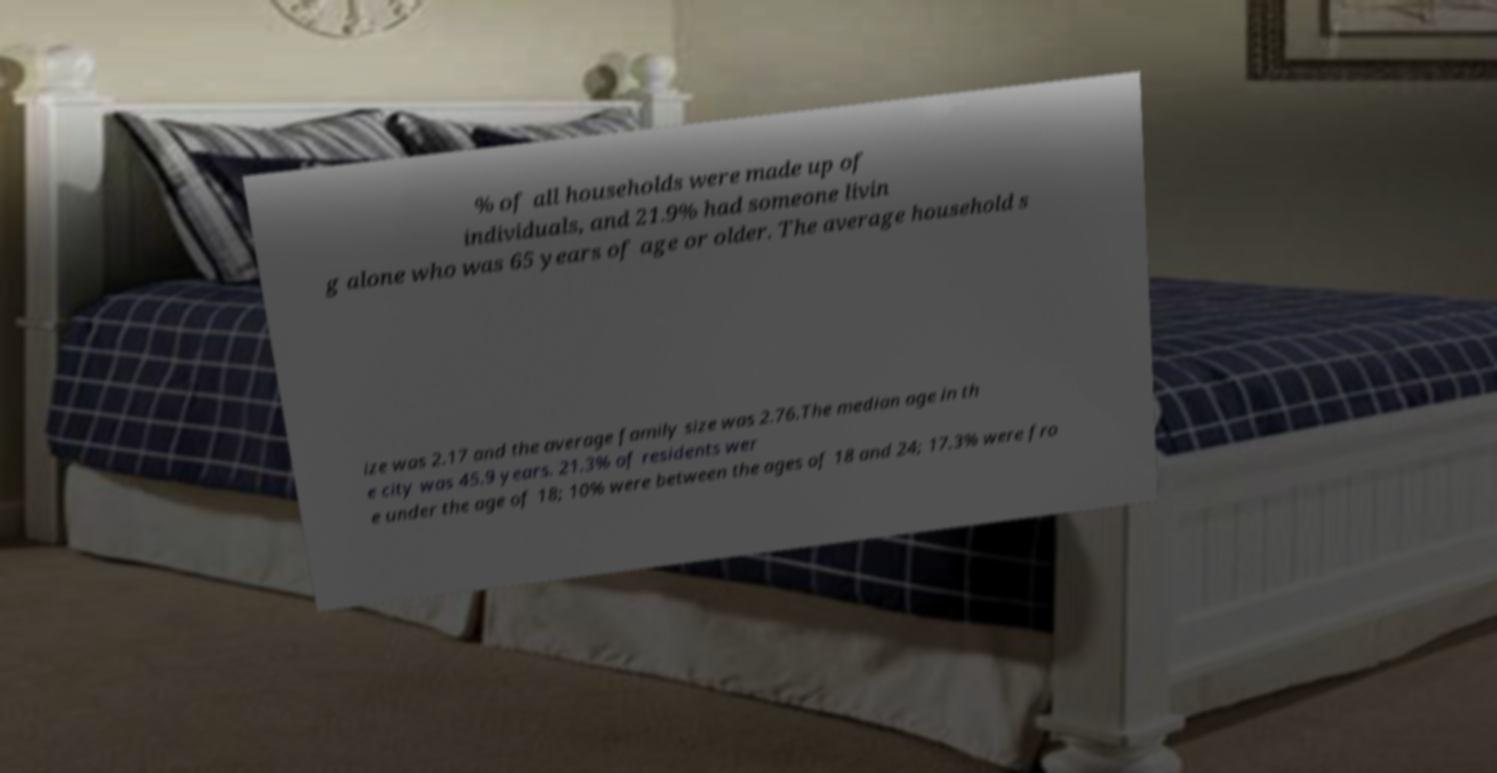Please identify and transcribe the text found in this image. % of all households were made up of individuals, and 21.9% had someone livin g alone who was 65 years of age or older. The average household s ize was 2.17 and the average family size was 2.76.The median age in th e city was 45.9 years. 21.3% of residents wer e under the age of 18; 10% were between the ages of 18 and 24; 17.3% were fro 